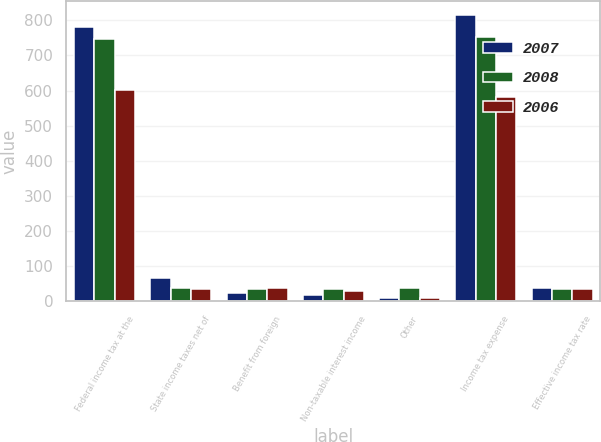Convert chart to OTSL. <chart><loc_0><loc_0><loc_500><loc_500><stacked_bar_chart><ecel><fcel>Federal income tax at the<fcel>State income taxes net of<fcel>Benefit from foreign<fcel>Non-taxable interest income<fcel>Other<fcel>Income tax expense<fcel>Effective income tax rate<nl><fcel>2007<fcel>780<fcel>67<fcel>25<fcel>17<fcel>10<fcel>815<fcel>36.6<nl><fcel>2008<fcel>747<fcel>38<fcel>36<fcel>34<fcel>37<fcel>752<fcel>35.3<nl><fcel>2006<fcel>603<fcel>34<fcel>37<fcel>28<fcel>9<fcel>581<fcel>33.7<nl></chart> 